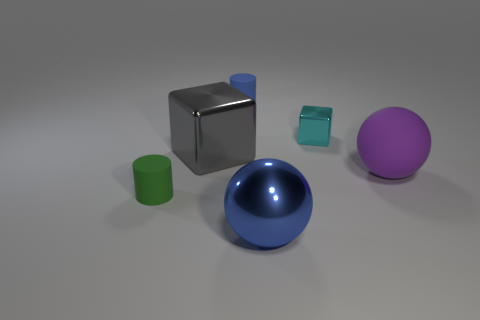Do the blue object behind the large purple matte sphere and the green object have the same shape? Yes, both the blue cube-like object behind the large purple matte sphere and the smaller green cylinder have geometric shapes with straight edges and flat faces, but they are distinct in shape; the blue object is a cube and the green object is a cylinder. 